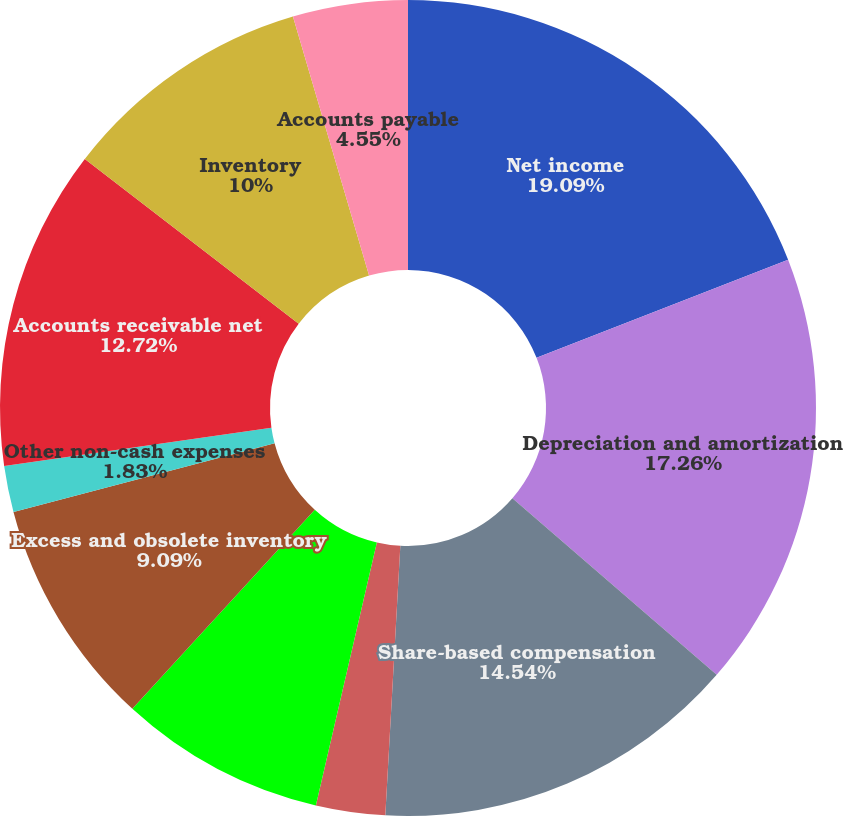Convert chart. <chart><loc_0><loc_0><loc_500><loc_500><pie_chart><fcel>Net income<fcel>Depreciation and amortization<fcel>Share-based compensation<fcel>Excess tax (benefit)<fcel>Deferred tax expense (benefit)<fcel>Excess and obsolete inventory<fcel>Other non-cash expenses<fcel>Accounts receivable net<fcel>Inventory<fcel>Accounts payable<nl><fcel>19.08%<fcel>17.26%<fcel>14.54%<fcel>2.74%<fcel>8.18%<fcel>9.09%<fcel>1.83%<fcel>12.72%<fcel>10.0%<fcel>4.55%<nl></chart> 